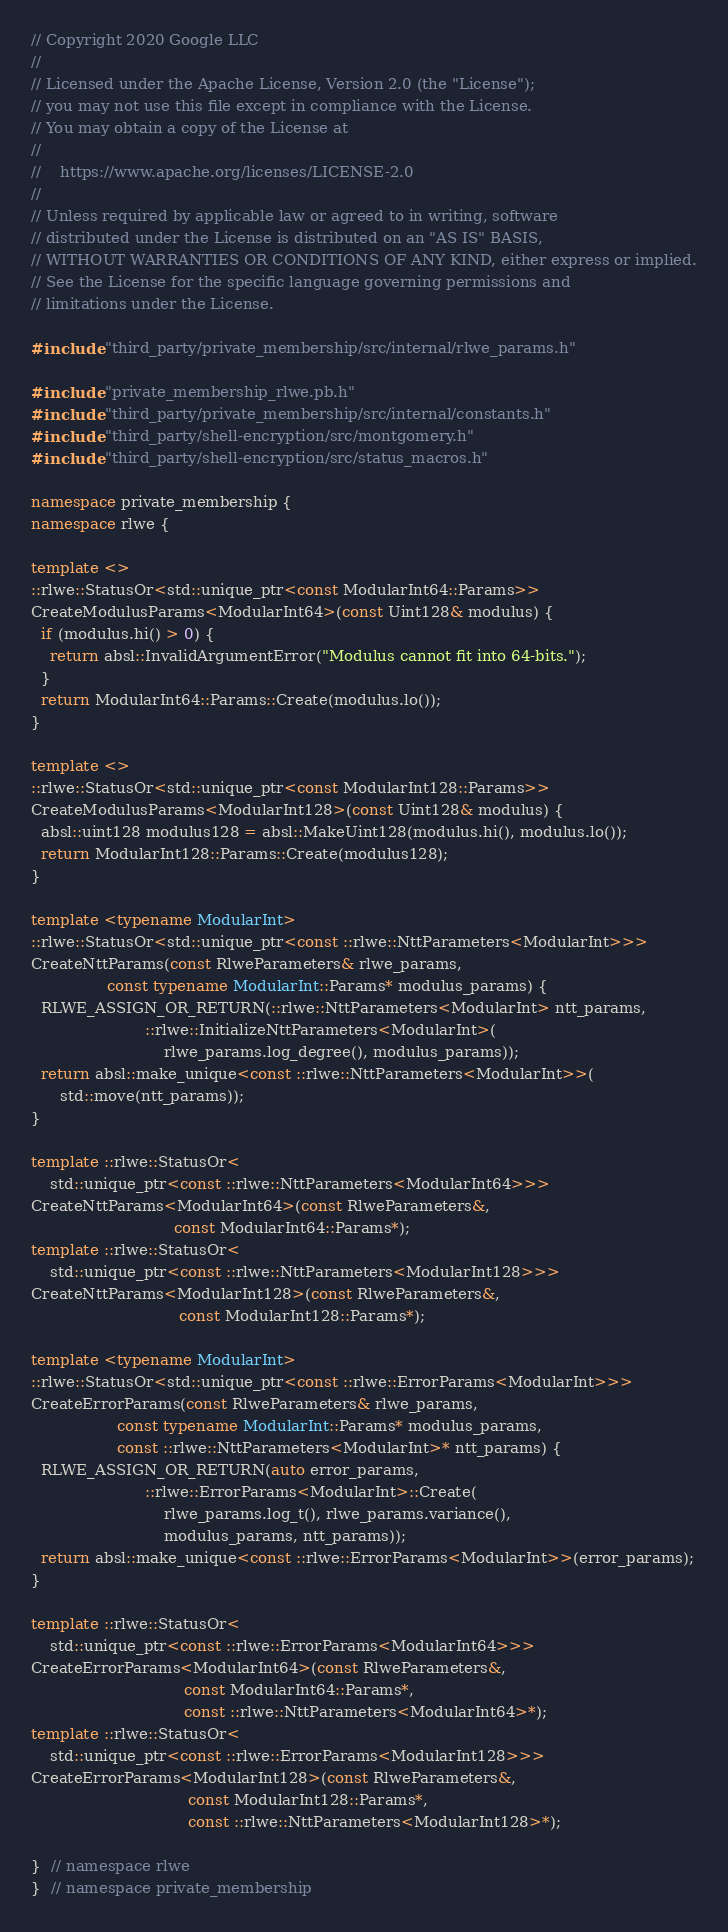Convert code to text. <code><loc_0><loc_0><loc_500><loc_500><_C++_>// Copyright 2020 Google LLC
//
// Licensed under the Apache License, Version 2.0 (the "License");
// you may not use this file except in compliance with the License.
// You may obtain a copy of the License at
//
//    https://www.apache.org/licenses/LICENSE-2.0
//
// Unless required by applicable law or agreed to in writing, software
// distributed under the License is distributed on an "AS IS" BASIS,
// WITHOUT WARRANTIES OR CONDITIONS OF ANY KIND, either express or implied.
// See the License for the specific language governing permissions and
// limitations under the License.

#include "third_party/private_membership/src/internal/rlwe_params.h"

#include "private_membership_rlwe.pb.h"
#include "third_party/private_membership/src/internal/constants.h"
#include "third_party/shell-encryption/src/montgomery.h"
#include "third_party/shell-encryption/src/status_macros.h"

namespace private_membership {
namespace rlwe {

template <>
::rlwe::StatusOr<std::unique_ptr<const ModularInt64::Params>>
CreateModulusParams<ModularInt64>(const Uint128& modulus) {
  if (modulus.hi() > 0) {
    return absl::InvalidArgumentError("Modulus cannot fit into 64-bits.");
  }
  return ModularInt64::Params::Create(modulus.lo());
}

template <>
::rlwe::StatusOr<std::unique_ptr<const ModularInt128::Params>>
CreateModulusParams<ModularInt128>(const Uint128& modulus) {
  absl::uint128 modulus128 = absl::MakeUint128(modulus.hi(), modulus.lo());
  return ModularInt128::Params::Create(modulus128);
}

template <typename ModularInt>
::rlwe::StatusOr<std::unique_ptr<const ::rlwe::NttParameters<ModularInt>>>
CreateNttParams(const RlweParameters& rlwe_params,
                const typename ModularInt::Params* modulus_params) {
  RLWE_ASSIGN_OR_RETURN(::rlwe::NttParameters<ModularInt> ntt_params,
                        ::rlwe::InitializeNttParameters<ModularInt>(
                            rlwe_params.log_degree(), modulus_params));
  return absl::make_unique<const ::rlwe::NttParameters<ModularInt>>(
      std::move(ntt_params));
}

template ::rlwe::StatusOr<
    std::unique_ptr<const ::rlwe::NttParameters<ModularInt64>>>
CreateNttParams<ModularInt64>(const RlweParameters&,
                              const ModularInt64::Params*);
template ::rlwe::StatusOr<
    std::unique_ptr<const ::rlwe::NttParameters<ModularInt128>>>
CreateNttParams<ModularInt128>(const RlweParameters&,
                               const ModularInt128::Params*);

template <typename ModularInt>
::rlwe::StatusOr<std::unique_ptr<const ::rlwe::ErrorParams<ModularInt>>>
CreateErrorParams(const RlweParameters& rlwe_params,
                  const typename ModularInt::Params* modulus_params,
                  const ::rlwe::NttParameters<ModularInt>* ntt_params) {
  RLWE_ASSIGN_OR_RETURN(auto error_params,
                        ::rlwe::ErrorParams<ModularInt>::Create(
                            rlwe_params.log_t(), rlwe_params.variance(),
                            modulus_params, ntt_params));
  return absl::make_unique<const ::rlwe::ErrorParams<ModularInt>>(error_params);
}

template ::rlwe::StatusOr<
    std::unique_ptr<const ::rlwe::ErrorParams<ModularInt64>>>
CreateErrorParams<ModularInt64>(const RlweParameters&,
                                const ModularInt64::Params*,
                                const ::rlwe::NttParameters<ModularInt64>*);
template ::rlwe::StatusOr<
    std::unique_ptr<const ::rlwe::ErrorParams<ModularInt128>>>
CreateErrorParams<ModularInt128>(const RlweParameters&,
                                 const ModularInt128::Params*,
                                 const ::rlwe::NttParameters<ModularInt128>*);

}  // namespace rlwe
}  // namespace private_membership
</code> 